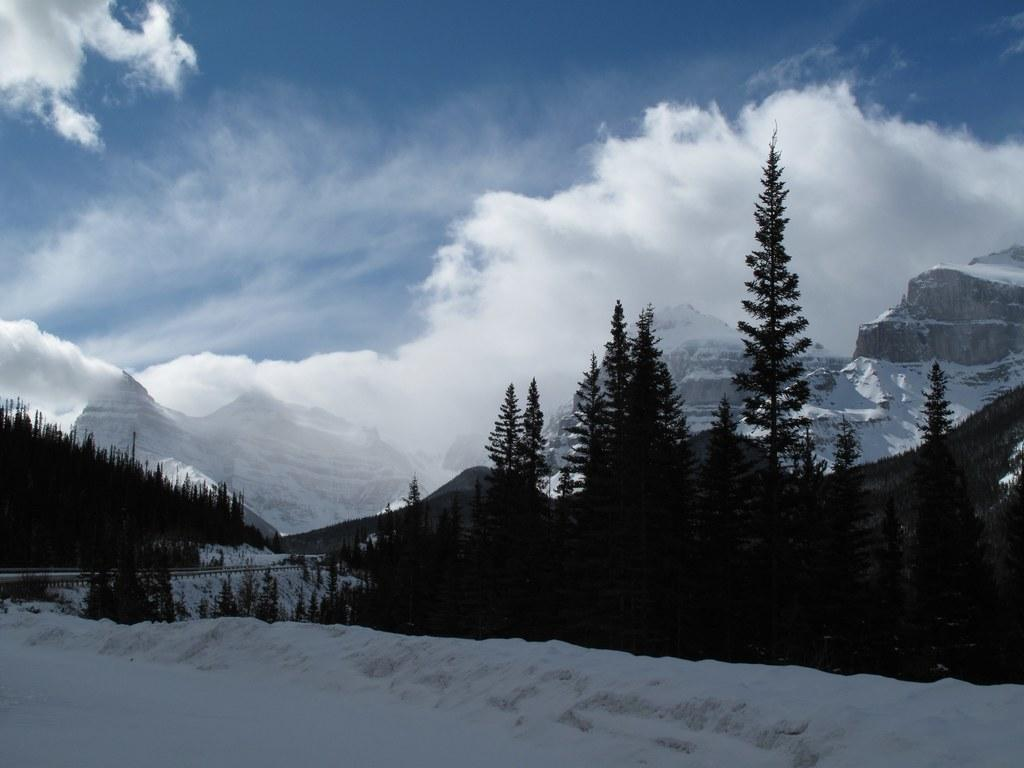What is covering the ground in the image? There is snow on the ground in the image. What type of vegetation can be seen in the image? There are trees in the image. What can be seen in the background of the image? There is snow on the mountains and clouds in the sky in the background of the image. Can you see a tiger walking through the snow in the image? No, there is no tiger present in the image. 